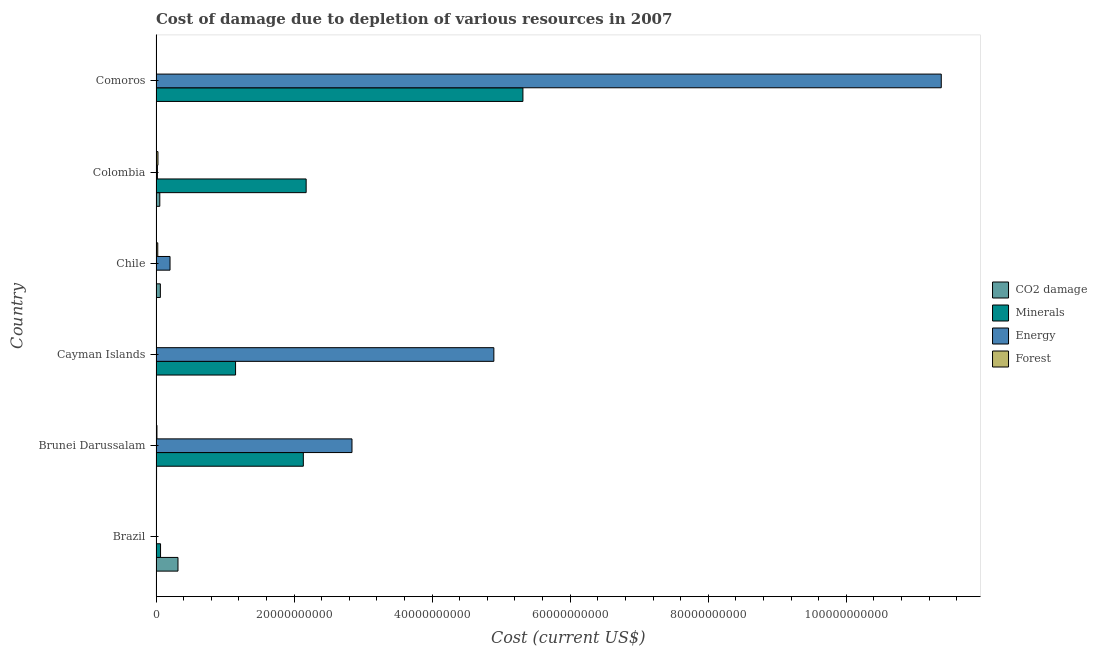How many different coloured bars are there?
Provide a succinct answer. 4. How many groups of bars are there?
Your answer should be compact. 6. Are the number of bars per tick equal to the number of legend labels?
Ensure brevity in your answer.  Yes. What is the label of the 5th group of bars from the top?
Offer a very short reply. Brunei Darussalam. What is the cost of damage due to depletion of minerals in Comoros?
Ensure brevity in your answer.  5.32e+1. Across all countries, what is the maximum cost of damage due to depletion of minerals?
Make the answer very short. 5.32e+1. Across all countries, what is the minimum cost of damage due to depletion of minerals?
Keep it short and to the point. 7.89e+05. In which country was the cost of damage due to depletion of energy maximum?
Keep it short and to the point. Comoros. What is the total cost of damage due to depletion of forests in the graph?
Make the answer very short. 7.13e+08. What is the difference between the cost of damage due to depletion of coal in Brazil and that in Brunei Darussalam?
Your response must be concise. 3.10e+09. What is the difference between the cost of damage due to depletion of forests in Colombia and the cost of damage due to depletion of energy in Comoros?
Give a very brief answer. -1.13e+11. What is the average cost of damage due to depletion of coal per country?
Provide a succinct answer. 7.40e+08. What is the difference between the cost of damage due to depletion of coal and cost of damage due to depletion of energy in Colombia?
Provide a succinct answer. 3.46e+08. What is the ratio of the cost of damage due to depletion of forests in Brazil to that in Chile?
Offer a very short reply. 0.02. Is the cost of damage due to depletion of coal in Brazil less than that in Cayman Islands?
Provide a succinct answer. No. Is the difference between the cost of damage due to depletion of forests in Brunei Darussalam and Comoros greater than the difference between the cost of damage due to depletion of energy in Brunei Darussalam and Comoros?
Your answer should be very brief. Yes. What is the difference between the highest and the second highest cost of damage due to depletion of coal?
Ensure brevity in your answer.  2.55e+09. What is the difference between the highest and the lowest cost of damage due to depletion of coal?
Your response must be concise. 3.18e+09. In how many countries, is the cost of damage due to depletion of forests greater than the average cost of damage due to depletion of forests taken over all countries?
Provide a succinct answer. 3. Is the sum of the cost of damage due to depletion of forests in Brazil and Brunei Darussalam greater than the maximum cost of damage due to depletion of coal across all countries?
Provide a succinct answer. No. Is it the case that in every country, the sum of the cost of damage due to depletion of coal and cost of damage due to depletion of forests is greater than the sum of cost of damage due to depletion of minerals and cost of damage due to depletion of energy?
Your response must be concise. No. What does the 1st bar from the top in Chile represents?
Keep it short and to the point. Forest. What does the 2nd bar from the bottom in Colombia represents?
Ensure brevity in your answer.  Minerals. How many bars are there?
Offer a very short reply. 24. Where does the legend appear in the graph?
Keep it short and to the point. Center right. How many legend labels are there?
Your response must be concise. 4. How are the legend labels stacked?
Your answer should be very brief. Vertical. What is the title of the graph?
Provide a short and direct response. Cost of damage due to depletion of various resources in 2007 . What is the label or title of the X-axis?
Ensure brevity in your answer.  Cost (current US$). What is the label or title of the Y-axis?
Your response must be concise. Country. What is the Cost (current US$) in CO2 damage in Brazil?
Keep it short and to the point. 3.18e+09. What is the Cost (current US$) in Minerals in Brazil?
Offer a very short reply. 6.55e+08. What is the Cost (current US$) of Energy in Brazil?
Provide a short and direct response. 9.09e+06. What is the Cost (current US$) in Forest in Brazil?
Provide a succinct answer. 4.64e+06. What is the Cost (current US$) of CO2 damage in Brunei Darussalam?
Your answer should be very brief. 7.93e+07. What is the Cost (current US$) of Minerals in Brunei Darussalam?
Keep it short and to the point. 2.13e+1. What is the Cost (current US$) in Energy in Brunei Darussalam?
Make the answer very short. 2.84e+1. What is the Cost (current US$) of Forest in Brunei Darussalam?
Provide a succinct answer. 1.34e+08. What is the Cost (current US$) of CO2 damage in Cayman Islands?
Offer a terse response. 5.11e+06. What is the Cost (current US$) in Minerals in Cayman Islands?
Provide a succinct answer. 1.15e+1. What is the Cost (current US$) in Energy in Cayman Islands?
Make the answer very short. 4.89e+1. What is the Cost (current US$) in Forest in Cayman Islands?
Provide a short and direct response. 1.26e+07. What is the Cost (current US$) in CO2 damage in Chile?
Provide a short and direct response. 6.27e+08. What is the Cost (current US$) of Minerals in Chile?
Offer a terse response. 7.89e+05. What is the Cost (current US$) of Energy in Chile?
Offer a very short reply. 2.03e+09. What is the Cost (current US$) in Forest in Chile?
Offer a terse response. 2.53e+08. What is the Cost (current US$) of CO2 damage in Colombia?
Your response must be concise. 5.47e+08. What is the Cost (current US$) in Minerals in Colombia?
Keep it short and to the point. 2.18e+1. What is the Cost (current US$) of Energy in Colombia?
Keep it short and to the point. 2.01e+08. What is the Cost (current US$) in Forest in Colombia?
Keep it short and to the point. 2.80e+08. What is the Cost (current US$) of CO2 damage in Comoros?
Keep it short and to the point. 1.03e+06. What is the Cost (current US$) of Minerals in Comoros?
Your answer should be compact. 5.32e+1. What is the Cost (current US$) of Energy in Comoros?
Your answer should be very brief. 1.14e+11. What is the Cost (current US$) of Forest in Comoros?
Offer a very short reply. 2.84e+07. Across all countries, what is the maximum Cost (current US$) of CO2 damage?
Your answer should be compact. 3.18e+09. Across all countries, what is the maximum Cost (current US$) in Minerals?
Keep it short and to the point. 5.32e+1. Across all countries, what is the maximum Cost (current US$) in Energy?
Offer a very short reply. 1.14e+11. Across all countries, what is the maximum Cost (current US$) in Forest?
Your response must be concise. 2.80e+08. Across all countries, what is the minimum Cost (current US$) of CO2 damage?
Your answer should be very brief. 1.03e+06. Across all countries, what is the minimum Cost (current US$) of Minerals?
Your response must be concise. 7.89e+05. Across all countries, what is the minimum Cost (current US$) in Energy?
Make the answer very short. 9.09e+06. Across all countries, what is the minimum Cost (current US$) of Forest?
Your answer should be compact. 4.64e+06. What is the total Cost (current US$) of CO2 damage in the graph?
Offer a terse response. 4.44e+09. What is the total Cost (current US$) in Minerals in the graph?
Offer a terse response. 1.08e+11. What is the total Cost (current US$) of Energy in the graph?
Your answer should be very brief. 1.93e+11. What is the total Cost (current US$) of Forest in the graph?
Your response must be concise. 7.13e+08. What is the difference between the Cost (current US$) of CO2 damage in Brazil and that in Brunei Darussalam?
Your answer should be very brief. 3.10e+09. What is the difference between the Cost (current US$) in Minerals in Brazil and that in Brunei Darussalam?
Your answer should be compact. -2.07e+1. What is the difference between the Cost (current US$) in Energy in Brazil and that in Brunei Darussalam?
Make the answer very short. -2.84e+1. What is the difference between the Cost (current US$) of Forest in Brazil and that in Brunei Darussalam?
Give a very brief answer. -1.29e+08. What is the difference between the Cost (current US$) in CO2 damage in Brazil and that in Cayman Islands?
Make the answer very short. 3.18e+09. What is the difference between the Cost (current US$) in Minerals in Brazil and that in Cayman Islands?
Provide a short and direct response. -1.09e+1. What is the difference between the Cost (current US$) in Energy in Brazil and that in Cayman Islands?
Offer a very short reply. -4.89e+1. What is the difference between the Cost (current US$) of Forest in Brazil and that in Cayman Islands?
Offer a terse response. -7.93e+06. What is the difference between the Cost (current US$) of CO2 damage in Brazil and that in Chile?
Make the answer very short. 2.55e+09. What is the difference between the Cost (current US$) of Minerals in Brazil and that in Chile?
Give a very brief answer. 6.54e+08. What is the difference between the Cost (current US$) of Energy in Brazil and that in Chile?
Make the answer very short. -2.02e+09. What is the difference between the Cost (current US$) of Forest in Brazil and that in Chile?
Your answer should be compact. -2.48e+08. What is the difference between the Cost (current US$) of CO2 damage in Brazil and that in Colombia?
Provide a short and direct response. 2.63e+09. What is the difference between the Cost (current US$) of Minerals in Brazil and that in Colombia?
Offer a terse response. -2.11e+1. What is the difference between the Cost (current US$) in Energy in Brazil and that in Colombia?
Provide a succinct answer. -1.92e+08. What is the difference between the Cost (current US$) in Forest in Brazil and that in Colombia?
Give a very brief answer. -2.76e+08. What is the difference between the Cost (current US$) of CO2 damage in Brazil and that in Comoros?
Keep it short and to the point. 3.18e+09. What is the difference between the Cost (current US$) of Minerals in Brazil and that in Comoros?
Your answer should be very brief. -5.25e+1. What is the difference between the Cost (current US$) of Energy in Brazil and that in Comoros?
Provide a short and direct response. -1.14e+11. What is the difference between the Cost (current US$) in Forest in Brazil and that in Comoros?
Ensure brevity in your answer.  -2.38e+07. What is the difference between the Cost (current US$) of CO2 damage in Brunei Darussalam and that in Cayman Islands?
Your response must be concise. 7.42e+07. What is the difference between the Cost (current US$) of Minerals in Brunei Darussalam and that in Cayman Islands?
Ensure brevity in your answer.  9.82e+09. What is the difference between the Cost (current US$) of Energy in Brunei Darussalam and that in Cayman Islands?
Your answer should be compact. -2.06e+1. What is the difference between the Cost (current US$) of Forest in Brunei Darussalam and that in Cayman Islands?
Keep it short and to the point. 1.21e+08. What is the difference between the Cost (current US$) of CO2 damage in Brunei Darussalam and that in Chile?
Your response must be concise. -5.48e+08. What is the difference between the Cost (current US$) of Minerals in Brunei Darussalam and that in Chile?
Ensure brevity in your answer.  2.13e+1. What is the difference between the Cost (current US$) in Energy in Brunei Darussalam and that in Chile?
Provide a short and direct response. 2.64e+1. What is the difference between the Cost (current US$) of Forest in Brunei Darussalam and that in Chile?
Your answer should be very brief. -1.19e+08. What is the difference between the Cost (current US$) of CO2 damage in Brunei Darussalam and that in Colombia?
Your answer should be compact. -4.67e+08. What is the difference between the Cost (current US$) of Minerals in Brunei Darussalam and that in Colombia?
Provide a short and direct response. -4.09e+08. What is the difference between the Cost (current US$) in Energy in Brunei Darussalam and that in Colombia?
Ensure brevity in your answer.  2.82e+1. What is the difference between the Cost (current US$) in Forest in Brunei Darussalam and that in Colombia?
Ensure brevity in your answer.  -1.46e+08. What is the difference between the Cost (current US$) in CO2 damage in Brunei Darussalam and that in Comoros?
Ensure brevity in your answer.  7.83e+07. What is the difference between the Cost (current US$) of Minerals in Brunei Darussalam and that in Comoros?
Ensure brevity in your answer.  -3.18e+1. What is the difference between the Cost (current US$) of Energy in Brunei Darussalam and that in Comoros?
Ensure brevity in your answer.  -8.54e+1. What is the difference between the Cost (current US$) of Forest in Brunei Darussalam and that in Comoros?
Provide a short and direct response. 1.05e+08. What is the difference between the Cost (current US$) of CO2 damage in Cayman Islands and that in Chile?
Your answer should be very brief. -6.22e+08. What is the difference between the Cost (current US$) in Minerals in Cayman Islands and that in Chile?
Make the answer very short. 1.15e+1. What is the difference between the Cost (current US$) in Energy in Cayman Islands and that in Chile?
Provide a succinct answer. 4.69e+1. What is the difference between the Cost (current US$) of Forest in Cayman Islands and that in Chile?
Your response must be concise. -2.40e+08. What is the difference between the Cost (current US$) of CO2 damage in Cayman Islands and that in Colombia?
Offer a very short reply. -5.42e+08. What is the difference between the Cost (current US$) of Minerals in Cayman Islands and that in Colombia?
Your response must be concise. -1.02e+1. What is the difference between the Cost (current US$) in Energy in Cayman Islands and that in Colombia?
Your answer should be compact. 4.87e+1. What is the difference between the Cost (current US$) of Forest in Cayman Islands and that in Colombia?
Your response must be concise. -2.68e+08. What is the difference between the Cost (current US$) in CO2 damage in Cayman Islands and that in Comoros?
Keep it short and to the point. 4.08e+06. What is the difference between the Cost (current US$) in Minerals in Cayman Islands and that in Comoros?
Make the answer very short. -4.16e+1. What is the difference between the Cost (current US$) in Energy in Cayman Islands and that in Comoros?
Offer a very short reply. -6.48e+1. What is the difference between the Cost (current US$) of Forest in Cayman Islands and that in Comoros?
Offer a terse response. -1.59e+07. What is the difference between the Cost (current US$) of CO2 damage in Chile and that in Colombia?
Your response must be concise. 8.06e+07. What is the difference between the Cost (current US$) in Minerals in Chile and that in Colombia?
Provide a succinct answer. -2.18e+1. What is the difference between the Cost (current US$) in Energy in Chile and that in Colombia?
Provide a succinct answer. 1.83e+09. What is the difference between the Cost (current US$) of Forest in Chile and that in Colombia?
Provide a succinct answer. -2.75e+07. What is the difference between the Cost (current US$) of CO2 damage in Chile and that in Comoros?
Provide a succinct answer. 6.26e+08. What is the difference between the Cost (current US$) of Minerals in Chile and that in Comoros?
Ensure brevity in your answer.  -5.32e+1. What is the difference between the Cost (current US$) in Energy in Chile and that in Comoros?
Offer a terse response. -1.12e+11. What is the difference between the Cost (current US$) of Forest in Chile and that in Comoros?
Make the answer very short. 2.24e+08. What is the difference between the Cost (current US$) of CO2 damage in Colombia and that in Comoros?
Your response must be concise. 5.46e+08. What is the difference between the Cost (current US$) of Minerals in Colombia and that in Comoros?
Provide a succinct answer. -3.14e+1. What is the difference between the Cost (current US$) in Energy in Colombia and that in Comoros?
Ensure brevity in your answer.  -1.14e+11. What is the difference between the Cost (current US$) of Forest in Colombia and that in Comoros?
Provide a short and direct response. 2.52e+08. What is the difference between the Cost (current US$) of CO2 damage in Brazil and the Cost (current US$) of Minerals in Brunei Darussalam?
Provide a short and direct response. -1.82e+1. What is the difference between the Cost (current US$) of CO2 damage in Brazil and the Cost (current US$) of Energy in Brunei Darussalam?
Provide a succinct answer. -2.52e+1. What is the difference between the Cost (current US$) in CO2 damage in Brazil and the Cost (current US$) in Forest in Brunei Darussalam?
Your answer should be compact. 3.05e+09. What is the difference between the Cost (current US$) in Minerals in Brazil and the Cost (current US$) in Energy in Brunei Darussalam?
Your answer should be very brief. -2.77e+1. What is the difference between the Cost (current US$) of Minerals in Brazil and the Cost (current US$) of Forest in Brunei Darussalam?
Keep it short and to the point. 5.21e+08. What is the difference between the Cost (current US$) in Energy in Brazil and the Cost (current US$) in Forest in Brunei Darussalam?
Your answer should be compact. -1.25e+08. What is the difference between the Cost (current US$) of CO2 damage in Brazil and the Cost (current US$) of Minerals in Cayman Islands?
Offer a very short reply. -8.34e+09. What is the difference between the Cost (current US$) in CO2 damage in Brazil and the Cost (current US$) in Energy in Cayman Islands?
Offer a very short reply. -4.58e+1. What is the difference between the Cost (current US$) of CO2 damage in Brazil and the Cost (current US$) of Forest in Cayman Islands?
Your answer should be very brief. 3.17e+09. What is the difference between the Cost (current US$) in Minerals in Brazil and the Cost (current US$) in Energy in Cayman Islands?
Offer a terse response. -4.83e+1. What is the difference between the Cost (current US$) in Minerals in Brazil and the Cost (current US$) in Forest in Cayman Islands?
Provide a short and direct response. 6.42e+08. What is the difference between the Cost (current US$) in Energy in Brazil and the Cost (current US$) in Forest in Cayman Islands?
Make the answer very short. -3.48e+06. What is the difference between the Cost (current US$) of CO2 damage in Brazil and the Cost (current US$) of Minerals in Chile?
Your answer should be very brief. 3.18e+09. What is the difference between the Cost (current US$) of CO2 damage in Brazil and the Cost (current US$) of Energy in Chile?
Make the answer very short. 1.15e+09. What is the difference between the Cost (current US$) of CO2 damage in Brazil and the Cost (current US$) of Forest in Chile?
Provide a short and direct response. 2.93e+09. What is the difference between the Cost (current US$) in Minerals in Brazil and the Cost (current US$) in Energy in Chile?
Make the answer very short. -1.37e+09. What is the difference between the Cost (current US$) in Minerals in Brazil and the Cost (current US$) in Forest in Chile?
Your answer should be compact. 4.02e+08. What is the difference between the Cost (current US$) of Energy in Brazil and the Cost (current US$) of Forest in Chile?
Make the answer very short. -2.44e+08. What is the difference between the Cost (current US$) of CO2 damage in Brazil and the Cost (current US$) of Minerals in Colombia?
Give a very brief answer. -1.86e+1. What is the difference between the Cost (current US$) in CO2 damage in Brazil and the Cost (current US$) in Energy in Colombia?
Keep it short and to the point. 2.98e+09. What is the difference between the Cost (current US$) of CO2 damage in Brazil and the Cost (current US$) of Forest in Colombia?
Your response must be concise. 2.90e+09. What is the difference between the Cost (current US$) in Minerals in Brazil and the Cost (current US$) in Energy in Colombia?
Provide a short and direct response. 4.54e+08. What is the difference between the Cost (current US$) in Minerals in Brazil and the Cost (current US$) in Forest in Colombia?
Keep it short and to the point. 3.75e+08. What is the difference between the Cost (current US$) in Energy in Brazil and the Cost (current US$) in Forest in Colombia?
Offer a terse response. -2.71e+08. What is the difference between the Cost (current US$) of CO2 damage in Brazil and the Cost (current US$) of Minerals in Comoros?
Your response must be concise. -5.00e+1. What is the difference between the Cost (current US$) in CO2 damage in Brazil and the Cost (current US$) in Energy in Comoros?
Provide a succinct answer. -1.11e+11. What is the difference between the Cost (current US$) of CO2 damage in Brazil and the Cost (current US$) of Forest in Comoros?
Ensure brevity in your answer.  3.15e+09. What is the difference between the Cost (current US$) in Minerals in Brazil and the Cost (current US$) in Energy in Comoros?
Offer a very short reply. -1.13e+11. What is the difference between the Cost (current US$) of Minerals in Brazil and the Cost (current US$) of Forest in Comoros?
Your answer should be compact. 6.26e+08. What is the difference between the Cost (current US$) in Energy in Brazil and the Cost (current US$) in Forest in Comoros?
Provide a succinct answer. -1.93e+07. What is the difference between the Cost (current US$) in CO2 damage in Brunei Darussalam and the Cost (current US$) in Minerals in Cayman Islands?
Your answer should be very brief. -1.14e+1. What is the difference between the Cost (current US$) in CO2 damage in Brunei Darussalam and the Cost (current US$) in Energy in Cayman Islands?
Offer a very short reply. -4.89e+1. What is the difference between the Cost (current US$) in CO2 damage in Brunei Darussalam and the Cost (current US$) in Forest in Cayman Islands?
Your answer should be compact. 6.67e+07. What is the difference between the Cost (current US$) in Minerals in Brunei Darussalam and the Cost (current US$) in Energy in Cayman Islands?
Offer a terse response. -2.76e+1. What is the difference between the Cost (current US$) of Minerals in Brunei Darussalam and the Cost (current US$) of Forest in Cayman Islands?
Provide a short and direct response. 2.13e+1. What is the difference between the Cost (current US$) of Energy in Brunei Darussalam and the Cost (current US$) of Forest in Cayman Islands?
Ensure brevity in your answer.  2.84e+1. What is the difference between the Cost (current US$) of CO2 damage in Brunei Darussalam and the Cost (current US$) of Minerals in Chile?
Offer a very short reply. 7.85e+07. What is the difference between the Cost (current US$) in CO2 damage in Brunei Darussalam and the Cost (current US$) in Energy in Chile?
Offer a very short reply. -1.95e+09. What is the difference between the Cost (current US$) of CO2 damage in Brunei Darussalam and the Cost (current US$) of Forest in Chile?
Your response must be concise. -1.74e+08. What is the difference between the Cost (current US$) in Minerals in Brunei Darussalam and the Cost (current US$) in Energy in Chile?
Ensure brevity in your answer.  1.93e+1. What is the difference between the Cost (current US$) of Minerals in Brunei Darussalam and the Cost (current US$) of Forest in Chile?
Provide a succinct answer. 2.11e+1. What is the difference between the Cost (current US$) in Energy in Brunei Darussalam and the Cost (current US$) in Forest in Chile?
Your answer should be compact. 2.81e+1. What is the difference between the Cost (current US$) in CO2 damage in Brunei Darussalam and the Cost (current US$) in Minerals in Colombia?
Keep it short and to the point. -2.17e+1. What is the difference between the Cost (current US$) of CO2 damage in Brunei Darussalam and the Cost (current US$) of Energy in Colombia?
Offer a very short reply. -1.21e+08. What is the difference between the Cost (current US$) in CO2 damage in Brunei Darussalam and the Cost (current US$) in Forest in Colombia?
Provide a short and direct response. -2.01e+08. What is the difference between the Cost (current US$) in Minerals in Brunei Darussalam and the Cost (current US$) in Energy in Colombia?
Your response must be concise. 2.11e+1. What is the difference between the Cost (current US$) of Minerals in Brunei Darussalam and the Cost (current US$) of Forest in Colombia?
Keep it short and to the point. 2.11e+1. What is the difference between the Cost (current US$) in Energy in Brunei Darussalam and the Cost (current US$) in Forest in Colombia?
Keep it short and to the point. 2.81e+1. What is the difference between the Cost (current US$) in CO2 damage in Brunei Darussalam and the Cost (current US$) in Minerals in Comoros?
Give a very brief answer. -5.31e+1. What is the difference between the Cost (current US$) of CO2 damage in Brunei Darussalam and the Cost (current US$) of Energy in Comoros?
Offer a terse response. -1.14e+11. What is the difference between the Cost (current US$) in CO2 damage in Brunei Darussalam and the Cost (current US$) in Forest in Comoros?
Offer a very short reply. 5.09e+07. What is the difference between the Cost (current US$) in Minerals in Brunei Darussalam and the Cost (current US$) in Energy in Comoros?
Ensure brevity in your answer.  -9.24e+1. What is the difference between the Cost (current US$) in Minerals in Brunei Darussalam and the Cost (current US$) in Forest in Comoros?
Your answer should be compact. 2.13e+1. What is the difference between the Cost (current US$) in Energy in Brunei Darussalam and the Cost (current US$) in Forest in Comoros?
Your response must be concise. 2.84e+1. What is the difference between the Cost (current US$) in CO2 damage in Cayman Islands and the Cost (current US$) in Minerals in Chile?
Make the answer very short. 4.32e+06. What is the difference between the Cost (current US$) of CO2 damage in Cayman Islands and the Cost (current US$) of Energy in Chile?
Offer a very short reply. -2.02e+09. What is the difference between the Cost (current US$) of CO2 damage in Cayman Islands and the Cost (current US$) of Forest in Chile?
Make the answer very short. -2.48e+08. What is the difference between the Cost (current US$) of Minerals in Cayman Islands and the Cost (current US$) of Energy in Chile?
Give a very brief answer. 9.49e+09. What is the difference between the Cost (current US$) of Minerals in Cayman Islands and the Cost (current US$) of Forest in Chile?
Give a very brief answer. 1.13e+1. What is the difference between the Cost (current US$) in Energy in Cayman Islands and the Cost (current US$) in Forest in Chile?
Ensure brevity in your answer.  4.87e+1. What is the difference between the Cost (current US$) in CO2 damage in Cayman Islands and the Cost (current US$) in Minerals in Colombia?
Your response must be concise. -2.17e+1. What is the difference between the Cost (current US$) in CO2 damage in Cayman Islands and the Cost (current US$) in Energy in Colombia?
Provide a short and direct response. -1.96e+08. What is the difference between the Cost (current US$) in CO2 damage in Cayman Islands and the Cost (current US$) in Forest in Colombia?
Ensure brevity in your answer.  -2.75e+08. What is the difference between the Cost (current US$) of Minerals in Cayman Islands and the Cost (current US$) of Energy in Colombia?
Your answer should be very brief. 1.13e+1. What is the difference between the Cost (current US$) of Minerals in Cayman Islands and the Cost (current US$) of Forest in Colombia?
Make the answer very short. 1.12e+1. What is the difference between the Cost (current US$) in Energy in Cayman Islands and the Cost (current US$) in Forest in Colombia?
Your answer should be very brief. 4.87e+1. What is the difference between the Cost (current US$) of CO2 damage in Cayman Islands and the Cost (current US$) of Minerals in Comoros?
Offer a very short reply. -5.32e+1. What is the difference between the Cost (current US$) in CO2 damage in Cayman Islands and the Cost (current US$) in Energy in Comoros?
Your answer should be very brief. -1.14e+11. What is the difference between the Cost (current US$) in CO2 damage in Cayman Islands and the Cost (current US$) in Forest in Comoros?
Your response must be concise. -2.33e+07. What is the difference between the Cost (current US$) of Minerals in Cayman Islands and the Cost (current US$) of Energy in Comoros?
Give a very brief answer. -1.02e+11. What is the difference between the Cost (current US$) in Minerals in Cayman Islands and the Cost (current US$) in Forest in Comoros?
Offer a very short reply. 1.15e+1. What is the difference between the Cost (current US$) in Energy in Cayman Islands and the Cost (current US$) in Forest in Comoros?
Your answer should be very brief. 4.89e+1. What is the difference between the Cost (current US$) of CO2 damage in Chile and the Cost (current US$) of Minerals in Colombia?
Your answer should be compact. -2.11e+1. What is the difference between the Cost (current US$) in CO2 damage in Chile and the Cost (current US$) in Energy in Colombia?
Keep it short and to the point. 4.27e+08. What is the difference between the Cost (current US$) of CO2 damage in Chile and the Cost (current US$) of Forest in Colombia?
Provide a succinct answer. 3.47e+08. What is the difference between the Cost (current US$) of Minerals in Chile and the Cost (current US$) of Energy in Colombia?
Offer a terse response. -2.00e+08. What is the difference between the Cost (current US$) of Minerals in Chile and the Cost (current US$) of Forest in Colombia?
Offer a terse response. -2.80e+08. What is the difference between the Cost (current US$) of Energy in Chile and the Cost (current US$) of Forest in Colombia?
Your response must be concise. 1.75e+09. What is the difference between the Cost (current US$) in CO2 damage in Chile and the Cost (current US$) in Minerals in Comoros?
Offer a terse response. -5.25e+1. What is the difference between the Cost (current US$) in CO2 damage in Chile and the Cost (current US$) in Energy in Comoros?
Your response must be concise. -1.13e+11. What is the difference between the Cost (current US$) of CO2 damage in Chile and the Cost (current US$) of Forest in Comoros?
Ensure brevity in your answer.  5.99e+08. What is the difference between the Cost (current US$) of Minerals in Chile and the Cost (current US$) of Energy in Comoros?
Offer a terse response. -1.14e+11. What is the difference between the Cost (current US$) in Minerals in Chile and the Cost (current US$) in Forest in Comoros?
Ensure brevity in your answer.  -2.77e+07. What is the difference between the Cost (current US$) in Energy in Chile and the Cost (current US$) in Forest in Comoros?
Provide a succinct answer. 2.00e+09. What is the difference between the Cost (current US$) of CO2 damage in Colombia and the Cost (current US$) of Minerals in Comoros?
Your response must be concise. -5.26e+1. What is the difference between the Cost (current US$) in CO2 damage in Colombia and the Cost (current US$) in Energy in Comoros?
Make the answer very short. -1.13e+11. What is the difference between the Cost (current US$) of CO2 damage in Colombia and the Cost (current US$) of Forest in Comoros?
Provide a short and direct response. 5.18e+08. What is the difference between the Cost (current US$) in Minerals in Colombia and the Cost (current US$) in Energy in Comoros?
Offer a terse response. -9.20e+1. What is the difference between the Cost (current US$) of Minerals in Colombia and the Cost (current US$) of Forest in Comoros?
Provide a short and direct response. 2.17e+1. What is the difference between the Cost (current US$) of Energy in Colombia and the Cost (current US$) of Forest in Comoros?
Keep it short and to the point. 1.72e+08. What is the average Cost (current US$) in CO2 damage per country?
Keep it short and to the point. 7.40e+08. What is the average Cost (current US$) in Minerals per country?
Your answer should be compact. 1.81e+1. What is the average Cost (current US$) of Energy per country?
Ensure brevity in your answer.  3.22e+1. What is the average Cost (current US$) in Forest per country?
Ensure brevity in your answer.  1.19e+08. What is the difference between the Cost (current US$) in CO2 damage and Cost (current US$) in Minerals in Brazil?
Provide a short and direct response. 2.53e+09. What is the difference between the Cost (current US$) of CO2 damage and Cost (current US$) of Energy in Brazil?
Offer a very short reply. 3.17e+09. What is the difference between the Cost (current US$) of CO2 damage and Cost (current US$) of Forest in Brazil?
Offer a terse response. 3.18e+09. What is the difference between the Cost (current US$) of Minerals and Cost (current US$) of Energy in Brazil?
Offer a terse response. 6.46e+08. What is the difference between the Cost (current US$) in Minerals and Cost (current US$) in Forest in Brazil?
Give a very brief answer. 6.50e+08. What is the difference between the Cost (current US$) in Energy and Cost (current US$) in Forest in Brazil?
Your answer should be very brief. 4.45e+06. What is the difference between the Cost (current US$) in CO2 damage and Cost (current US$) in Minerals in Brunei Darussalam?
Offer a terse response. -2.13e+1. What is the difference between the Cost (current US$) in CO2 damage and Cost (current US$) in Energy in Brunei Darussalam?
Offer a terse response. -2.83e+1. What is the difference between the Cost (current US$) in CO2 damage and Cost (current US$) in Forest in Brunei Darussalam?
Your response must be concise. -5.46e+07. What is the difference between the Cost (current US$) of Minerals and Cost (current US$) of Energy in Brunei Darussalam?
Offer a terse response. -7.05e+09. What is the difference between the Cost (current US$) of Minerals and Cost (current US$) of Forest in Brunei Darussalam?
Provide a succinct answer. 2.12e+1. What is the difference between the Cost (current US$) of Energy and Cost (current US$) of Forest in Brunei Darussalam?
Provide a short and direct response. 2.83e+1. What is the difference between the Cost (current US$) of CO2 damage and Cost (current US$) of Minerals in Cayman Islands?
Offer a terse response. -1.15e+1. What is the difference between the Cost (current US$) of CO2 damage and Cost (current US$) of Energy in Cayman Islands?
Offer a terse response. -4.89e+1. What is the difference between the Cost (current US$) of CO2 damage and Cost (current US$) of Forest in Cayman Islands?
Offer a terse response. -7.47e+06. What is the difference between the Cost (current US$) in Minerals and Cost (current US$) in Energy in Cayman Islands?
Provide a succinct answer. -3.74e+1. What is the difference between the Cost (current US$) of Minerals and Cost (current US$) of Forest in Cayman Islands?
Your answer should be compact. 1.15e+1. What is the difference between the Cost (current US$) in Energy and Cost (current US$) in Forest in Cayman Islands?
Your response must be concise. 4.89e+1. What is the difference between the Cost (current US$) of CO2 damage and Cost (current US$) of Minerals in Chile?
Your answer should be very brief. 6.27e+08. What is the difference between the Cost (current US$) in CO2 damage and Cost (current US$) in Energy in Chile?
Offer a very short reply. -1.40e+09. What is the difference between the Cost (current US$) of CO2 damage and Cost (current US$) of Forest in Chile?
Offer a very short reply. 3.75e+08. What is the difference between the Cost (current US$) in Minerals and Cost (current US$) in Energy in Chile?
Offer a terse response. -2.03e+09. What is the difference between the Cost (current US$) of Minerals and Cost (current US$) of Forest in Chile?
Make the answer very short. -2.52e+08. What is the difference between the Cost (current US$) of Energy and Cost (current US$) of Forest in Chile?
Make the answer very short. 1.78e+09. What is the difference between the Cost (current US$) in CO2 damage and Cost (current US$) in Minerals in Colombia?
Provide a short and direct response. -2.12e+1. What is the difference between the Cost (current US$) in CO2 damage and Cost (current US$) in Energy in Colombia?
Your answer should be compact. 3.46e+08. What is the difference between the Cost (current US$) in CO2 damage and Cost (current US$) in Forest in Colombia?
Offer a terse response. 2.66e+08. What is the difference between the Cost (current US$) in Minerals and Cost (current US$) in Energy in Colombia?
Ensure brevity in your answer.  2.16e+1. What is the difference between the Cost (current US$) of Minerals and Cost (current US$) of Forest in Colombia?
Keep it short and to the point. 2.15e+1. What is the difference between the Cost (current US$) in Energy and Cost (current US$) in Forest in Colombia?
Your answer should be compact. -7.96e+07. What is the difference between the Cost (current US$) in CO2 damage and Cost (current US$) in Minerals in Comoros?
Provide a succinct answer. -5.32e+1. What is the difference between the Cost (current US$) in CO2 damage and Cost (current US$) in Energy in Comoros?
Keep it short and to the point. -1.14e+11. What is the difference between the Cost (current US$) of CO2 damage and Cost (current US$) of Forest in Comoros?
Your answer should be compact. -2.74e+07. What is the difference between the Cost (current US$) in Minerals and Cost (current US$) in Energy in Comoros?
Your answer should be very brief. -6.06e+1. What is the difference between the Cost (current US$) in Minerals and Cost (current US$) in Forest in Comoros?
Your answer should be very brief. 5.31e+1. What is the difference between the Cost (current US$) in Energy and Cost (current US$) in Forest in Comoros?
Offer a terse response. 1.14e+11. What is the ratio of the Cost (current US$) of CO2 damage in Brazil to that in Brunei Darussalam?
Offer a very short reply. 40.12. What is the ratio of the Cost (current US$) in Minerals in Brazil to that in Brunei Darussalam?
Offer a terse response. 0.03. What is the ratio of the Cost (current US$) of Energy in Brazil to that in Brunei Darussalam?
Ensure brevity in your answer.  0. What is the ratio of the Cost (current US$) of Forest in Brazil to that in Brunei Darussalam?
Your answer should be compact. 0.03. What is the ratio of the Cost (current US$) of CO2 damage in Brazil to that in Cayman Islands?
Your response must be concise. 622.95. What is the ratio of the Cost (current US$) in Minerals in Brazil to that in Cayman Islands?
Your answer should be compact. 0.06. What is the ratio of the Cost (current US$) of Forest in Brazil to that in Cayman Islands?
Provide a short and direct response. 0.37. What is the ratio of the Cost (current US$) in CO2 damage in Brazil to that in Chile?
Offer a very short reply. 5.07. What is the ratio of the Cost (current US$) in Minerals in Brazil to that in Chile?
Your response must be concise. 829.82. What is the ratio of the Cost (current US$) of Energy in Brazil to that in Chile?
Offer a terse response. 0. What is the ratio of the Cost (current US$) in Forest in Brazil to that in Chile?
Provide a short and direct response. 0.02. What is the ratio of the Cost (current US$) of CO2 damage in Brazil to that in Colombia?
Provide a succinct answer. 5.82. What is the ratio of the Cost (current US$) in Minerals in Brazil to that in Colombia?
Your answer should be compact. 0.03. What is the ratio of the Cost (current US$) of Energy in Brazil to that in Colombia?
Provide a short and direct response. 0.05. What is the ratio of the Cost (current US$) of Forest in Brazil to that in Colombia?
Make the answer very short. 0.02. What is the ratio of the Cost (current US$) of CO2 damage in Brazil to that in Comoros?
Your answer should be very brief. 3095.28. What is the ratio of the Cost (current US$) in Minerals in Brazil to that in Comoros?
Provide a succinct answer. 0.01. What is the ratio of the Cost (current US$) of Energy in Brazil to that in Comoros?
Offer a very short reply. 0. What is the ratio of the Cost (current US$) of Forest in Brazil to that in Comoros?
Make the answer very short. 0.16. What is the ratio of the Cost (current US$) of CO2 damage in Brunei Darussalam to that in Cayman Islands?
Make the answer very short. 15.53. What is the ratio of the Cost (current US$) of Minerals in Brunei Darussalam to that in Cayman Islands?
Your response must be concise. 1.85. What is the ratio of the Cost (current US$) of Energy in Brunei Darussalam to that in Cayman Islands?
Provide a short and direct response. 0.58. What is the ratio of the Cost (current US$) in Forest in Brunei Darussalam to that in Cayman Islands?
Offer a terse response. 10.65. What is the ratio of the Cost (current US$) of CO2 damage in Brunei Darussalam to that in Chile?
Ensure brevity in your answer.  0.13. What is the ratio of the Cost (current US$) in Minerals in Brunei Darussalam to that in Chile?
Keep it short and to the point. 2.70e+04. What is the ratio of the Cost (current US$) in Energy in Brunei Darussalam to that in Chile?
Provide a succinct answer. 13.99. What is the ratio of the Cost (current US$) of Forest in Brunei Darussalam to that in Chile?
Provide a succinct answer. 0.53. What is the ratio of the Cost (current US$) in CO2 damage in Brunei Darussalam to that in Colombia?
Keep it short and to the point. 0.14. What is the ratio of the Cost (current US$) of Minerals in Brunei Darussalam to that in Colombia?
Give a very brief answer. 0.98. What is the ratio of the Cost (current US$) of Energy in Brunei Darussalam to that in Colombia?
Provide a short and direct response. 141.41. What is the ratio of the Cost (current US$) in Forest in Brunei Darussalam to that in Colombia?
Ensure brevity in your answer.  0.48. What is the ratio of the Cost (current US$) in CO2 damage in Brunei Darussalam to that in Comoros?
Offer a terse response. 77.16. What is the ratio of the Cost (current US$) in Minerals in Brunei Darussalam to that in Comoros?
Your answer should be very brief. 0.4. What is the ratio of the Cost (current US$) of Energy in Brunei Darussalam to that in Comoros?
Provide a succinct answer. 0.25. What is the ratio of the Cost (current US$) of Forest in Brunei Darussalam to that in Comoros?
Provide a succinct answer. 4.71. What is the ratio of the Cost (current US$) in CO2 damage in Cayman Islands to that in Chile?
Provide a short and direct response. 0.01. What is the ratio of the Cost (current US$) of Minerals in Cayman Islands to that in Chile?
Offer a terse response. 1.46e+04. What is the ratio of the Cost (current US$) of Energy in Cayman Islands to that in Chile?
Ensure brevity in your answer.  24.13. What is the ratio of the Cost (current US$) of Forest in Cayman Islands to that in Chile?
Offer a terse response. 0.05. What is the ratio of the Cost (current US$) of CO2 damage in Cayman Islands to that in Colombia?
Your answer should be very brief. 0.01. What is the ratio of the Cost (current US$) of Minerals in Cayman Islands to that in Colombia?
Offer a very short reply. 0.53. What is the ratio of the Cost (current US$) of Energy in Cayman Islands to that in Colombia?
Provide a succinct answer. 243.8. What is the ratio of the Cost (current US$) of Forest in Cayman Islands to that in Colombia?
Your answer should be very brief. 0.04. What is the ratio of the Cost (current US$) of CO2 damage in Cayman Islands to that in Comoros?
Keep it short and to the point. 4.97. What is the ratio of the Cost (current US$) of Minerals in Cayman Islands to that in Comoros?
Your answer should be compact. 0.22. What is the ratio of the Cost (current US$) in Energy in Cayman Islands to that in Comoros?
Your response must be concise. 0.43. What is the ratio of the Cost (current US$) of Forest in Cayman Islands to that in Comoros?
Your answer should be very brief. 0.44. What is the ratio of the Cost (current US$) in CO2 damage in Chile to that in Colombia?
Provide a succinct answer. 1.15. What is the ratio of the Cost (current US$) of Energy in Chile to that in Colombia?
Give a very brief answer. 10.1. What is the ratio of the Cost (current US$) in Forest in Chile to that in Colombia?
Your answer should be very brief. 0.9. What is the ratio of the Cost (current US$) in CO2 damage in Chile to that in Comoros?
Offer a terse response. 610.5. What is the ratio of the Cost (current US$) of Energy in Chile to that in Comoros?
Give a very brief answer. 0.02. What is the ratio of the Cost (current US$) in Forest in Chile to that in Comoros?
Keep it short and to the point. 8.89. What is the ratio of the Cost (current US$) of CO2 damage in Colombia to that in Comoros?
Provide a succinct answer. 532.03. What is the ratio of the Cost (current US$) in Minerals in Colombia to that in Comoros?
Make the answer very short. 0.41. What is the ratio of the Cost (current US$) in Energy in Colombia to that in Comoros?
Offer a terse response. 0. What is the ratio of the Cost (current US$) of Forest in Colombia to that in Comoros?
Ensure brevity in your answer.  9.86. What is the difference between the highest and the second highest Cost (current US$) in CO2 damage?
Your response must be concise. 2.55e+09. What is the difference between the highest and the second highest Cost (current US$) of Minerals?
Your answer should be compact. 3.14e+1. What is the difference between the highest and the second highest Cost (current US$) of Energy?
Ensure brevity in your answer.  6.48e+1. What is the difference between the highest and the second highest Cost (current US$) of Forest?
Offer a very short reply. 2.75e+07. What is the difference between the highest and the lowest Cost (current US$) of CO2 damage?
Your answer should be compact. 3.18e+09. What is the difference between the highest and the lowest Cost (current US$) in Minerals?
Keep it short and to the point. 5.32e+1. What is the difference between the highest and the lowest Cost (current US$) of Energy?
Provide a succinct answer. 1.14e+11. What is the difference between the highest and the lowest Cost (current US$) of Forest?
Your answer should be compact. 2.76e+08. 